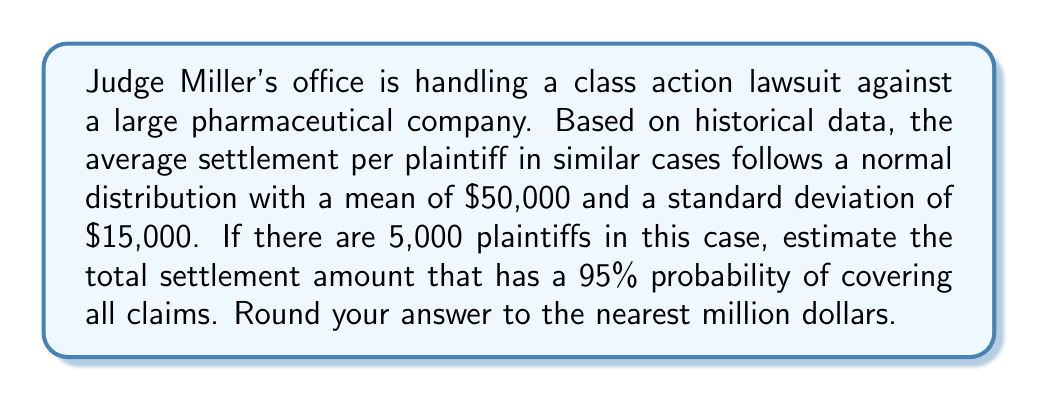Give your solution to this math problem. To solve this problem, we need to use the properties of normal distribution and the concept of confidence intervals. Here's a step-by-step approach:

1. Identify the given information:
   - Mean settlement per plaintiff: $\mu = \$50,000$
   - Standard deviation: $\sigma = \$15,000$
   - Number of plaintiffs: $n = 5,000$
   - Desired confidence level: 95%

2. For a 95% confidence level, we need to use a z-score of 1.96 (from the standard normal distribution table).

3. Calculate the standard error of the mean:
   $SE = \frac{\sigma}{\sqrt{n}} = \frac{\$15,000}{\sqrt{5,000}} = \$212.13$

4. Calculate the margin of error:
   $ME = z \times SE = 1.96 \times \$212.13 = \$415.77$

5. Calculate the upper bound of the confidence interval for the mean settlement:
   $\text{Upper Bound} = \mu + ME = \$50,000 + \$415.77 = \$50,415.77$

6. Multiply the upper bound by the number of plaintiffs to get the total settlement amount:
   $\text{Total Settlement} = \$50,415.77 \times 5,000 = \$252,078,850$

7. Round to the nearest million dollars:
   $\$252,078,850 \approx \$252,000,000$

This amount represents the total settlement that has a 95% probability of covering all claims, based on the given statistical model.
Answer: $252 million 